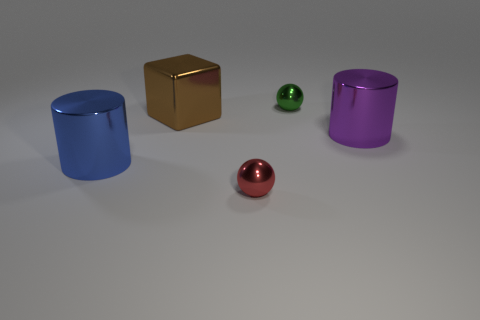What number of red objects have the same material as the brown block?
Your answer should be compact. 1. Are any brown metal things visible?
Make the answer very short. Yes. There is a shiny cylinder that is on the right side of the large blue cylinder; how big is it?
Keep it short and to the point. Large. What number of large things have the same color as the metal cube?
Offer a very short reply. 0. What number of spheres are either metal things or purple metallic objects?
Your response must be concise. 2. What is the shape of the large object that is in front of the brown thing and on the left side of the tiny red thing?
Your answer should be compact. Cylinder. Are there any green objects of the same size as the green metallic ball?
Ensure brevity in your answer.  No. What number of things are either small objects that are in front of the large blue shiny cylinder or red shiny cubes?
Ensure brevity in your answer.  1. Is the material of the brown block the same as the tiny sphere that is on the left side of the tiny green ball?
Ensure brevity in your answer.  Yes. How many other things are there of the same shape as the big blue shiny object?
Offer a very short reply. 1. 